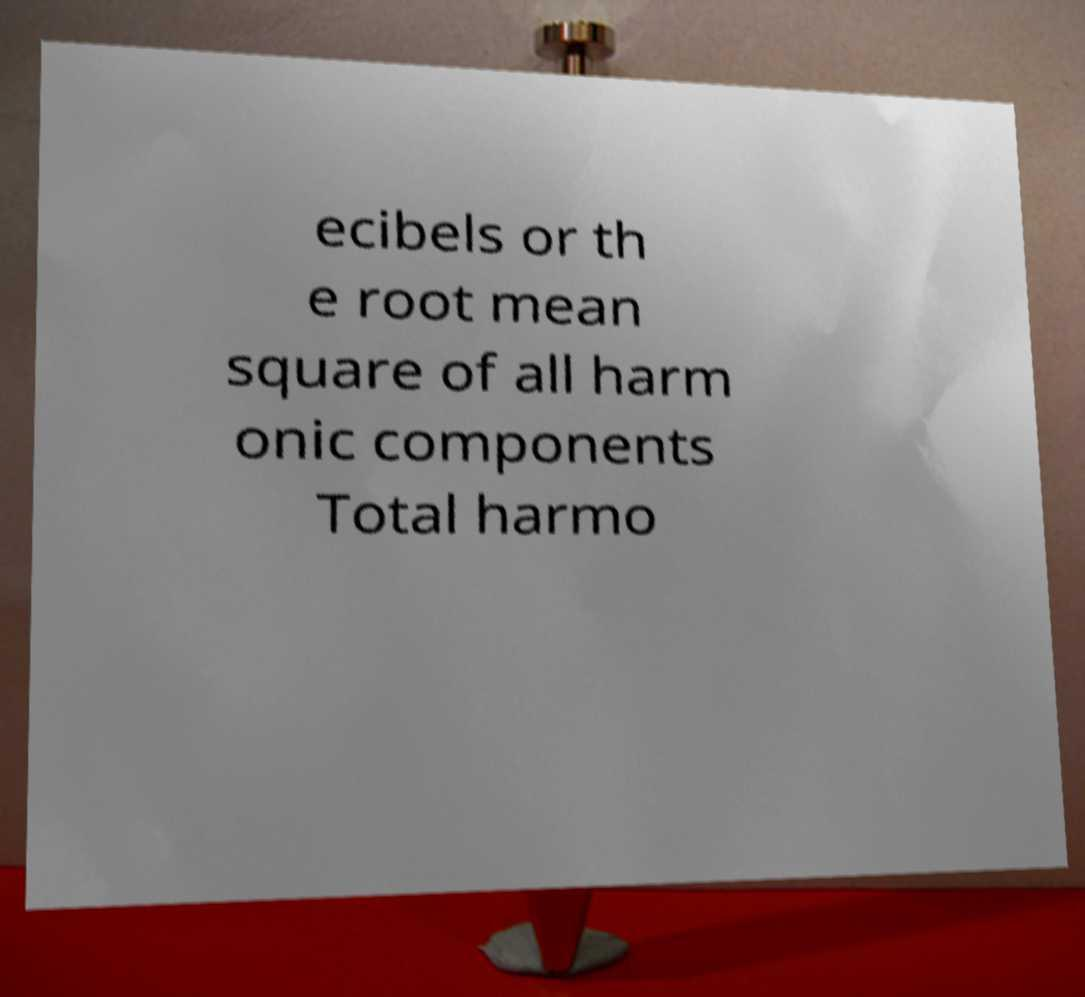Could you assist in decoding the text presented in this image and type it out clearly? ecibels or th e root mean square of all harm onic components Total harmo 